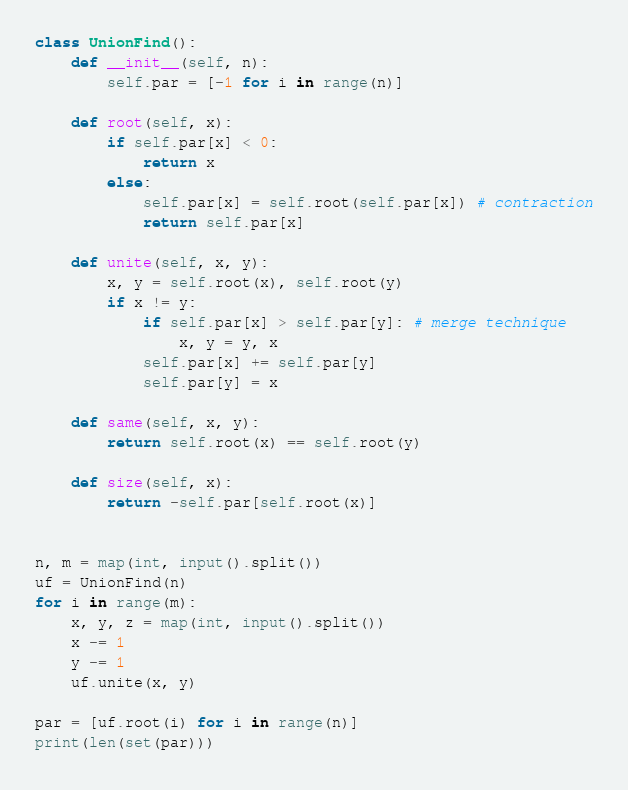<code> <loc_0><loc_0><loc_500><loc_500><_Python_>class UnionFind():
    def __init__(self, n):
        self.par = [-1 for i in range(n)]

    def root(self, x):
        if self.par[x] < 0:
            return x
        else:
            self.par[x] = self.root(self.par[x]) # contraction
            return self.par[x]

    def unite(self, x, y):
        x, y = self.root(x), self.root(y)
        if x != y:
            if self.par[x] > self.par[y]: # merge technique
                x, y = y, x
            self.par[x] += self.par[y]
            self.par[y] = x

    def same(self, x, y):
        return self.root(x) == self.root(y)

    def size(self, x):
        return -self.par[self.root(x)]


n, m = map(int, input().split())
uf = UnionFind(n)
for i in range(m):
    x, y, z = map(int, input().split())
    x -= 1
    y -= 1
    uf.unite(x, y)

par = [uf.root(i) for i in range(n)]
print(len(set(par)))
</code> 